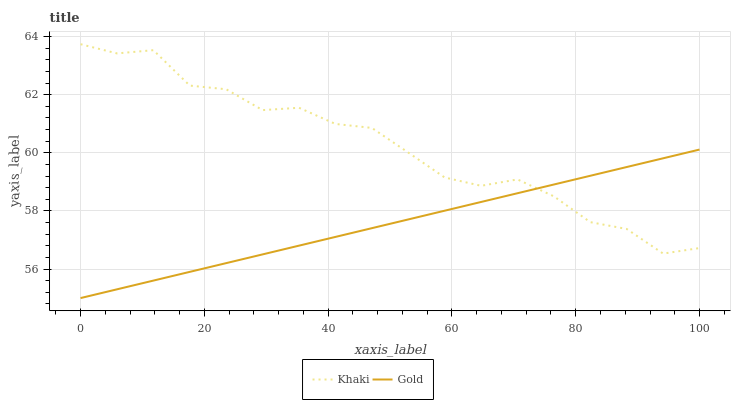Does Gold have the minimum area under the curve?
Answer yes or no. Yes. Does Khaki have the maximum area under the curve?
Answer yes or no. Yes. Does Gold have the maximum area under the curve?
Answer yes or no. No. Is Gold the smoothest?
Answer yes or no. Yes. Is Khaki the roughest?
Answer yes or no. Yes. Is Gold the roughest?
Answer yes or no. No. Does Gold have the lowest value?
Answer yes or no. Yes. Does Khaki have the highest value?
Answer yes or no. Yes. Does Gold have the highest value?
Answer yes or no. No. Does Khaki intersect Gold?
Answer yes or no. Yes. Is Khaki less than Gold?
Answer yes or no. No. Is Khaki greater than Gold?
Answer yes or no. No. 